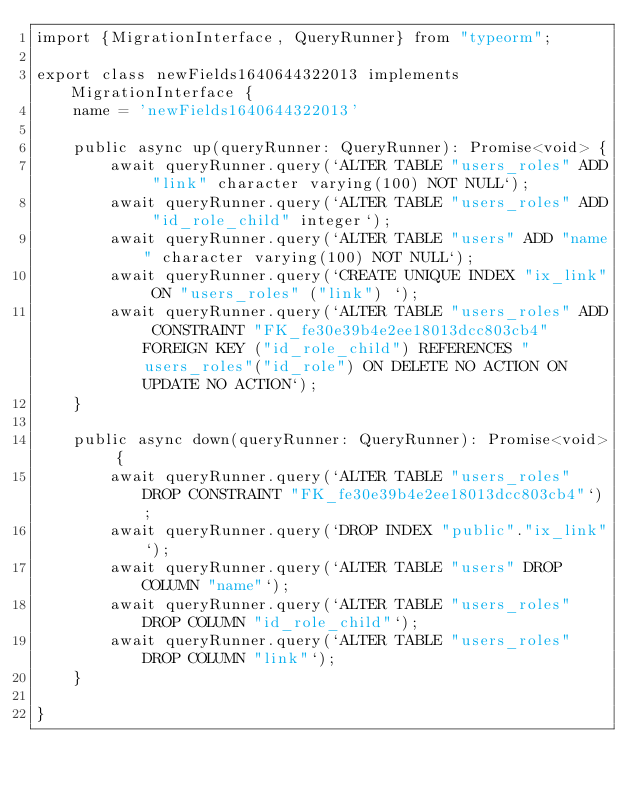<code> <loc_0><loc_0><loc_500><loc_500><_TypeScript_>import {MigrationInterface, QueryRunner} from "typeorm";

export class newFields1640644322013 implements MigrationInterface {
    name = 'newFields1640644322013'

    public async up(queryRunner: QueryRunner): Promise<void> {
        await queryRunner.query(`ALTER TABLE "users_roles" ADD "link" character varying(100) NOT NULL`);
        await queryRunner.query(`ALTER TABLE "users_roles" ADD "id_role_child" integer`);
        await queryRunner.query(`ALTER TABLE "users" ADD "name" character varying(100) NOT NULL`);
        await queryRunner.query(`CREATE UNIQUE INDEX "ix_link" ON "users_roles" ("link") `);
        await queryRunner.query(`ALTER TABLE "users_roles" ADD CONSTRAINT "FK_fe30e39b4e2ee18013dcc803cb4" FOREIGN KEY ("id_role_child") REFERENCES "users_roles"("id_role") ON DELETE NO ACTION ON UPDATE NO ACTION`);
    }

    public async down(queryRunner: QueryRunner): Promise<void> {
        await queryRunner.query(`ALTER TABLE "users_roles" DROP CONSTRAINT "FK_fe30e39b4e2ee18013dcc803cb4"`);
        await queryRunner.query(`DROP INDEX "public"."ix_link"`);
        await queryRunner.query(`ALTER TABLE "users" DROP COLUMN "name"`);
        await queryRunner.query(`ALTER TABLE "users_roles" DROP COLUMN "id_role_child"`);
        await queryRunner.query(`ALTER TABLE "users_roles" DROP COLUMN "link"`);
    }

}
</code> 